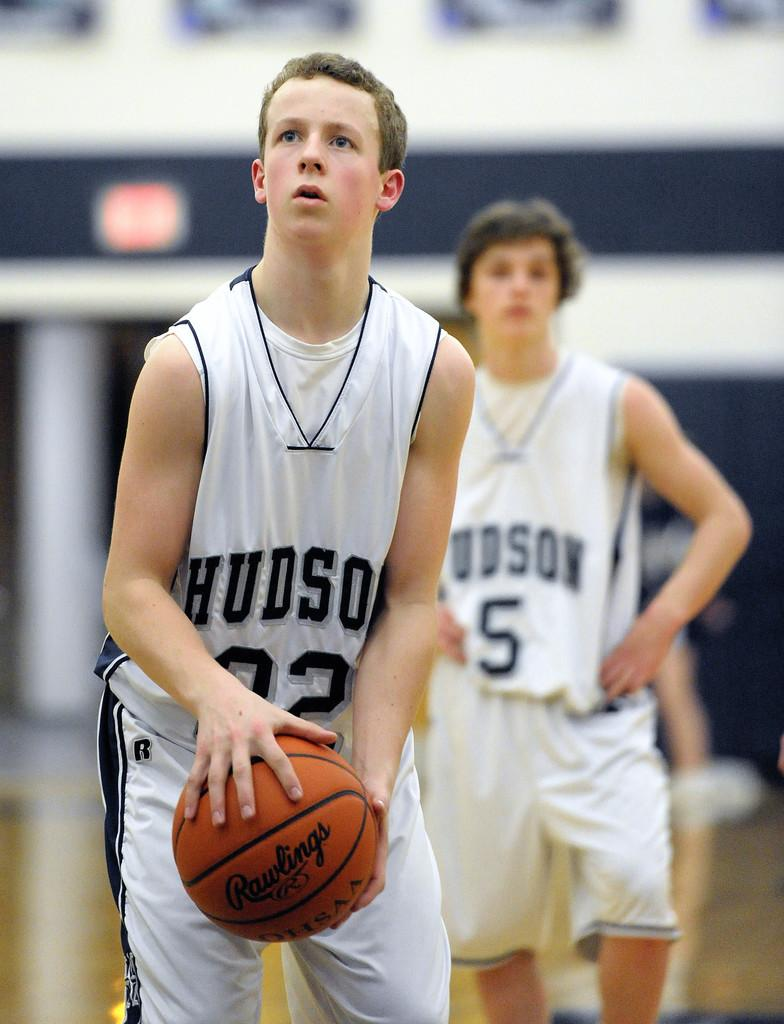<image>
Create a compact narrative representing the image presented. A basketball player stand behind another and has the number five on his jersey. 